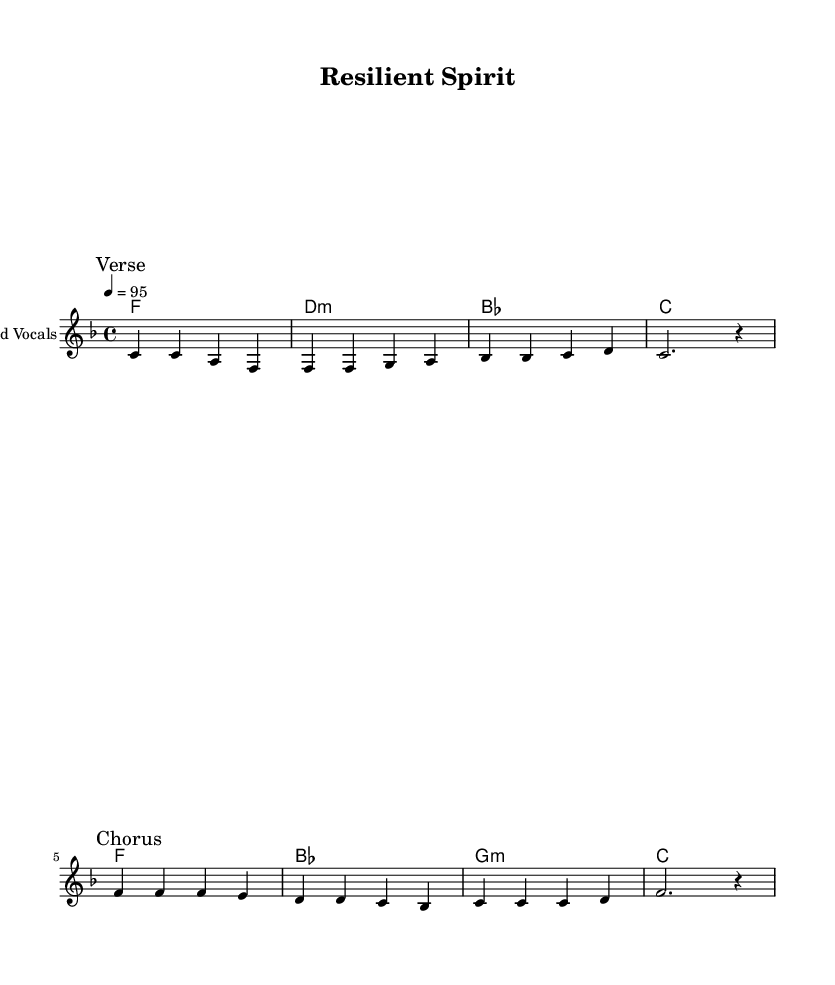What is the key signature of this music? The key signature is F major, identifiable by the presence of one flat (B flat). This can be determined by looking at the beginning of the sheet music where the key signature is indicated.
Answer: F major What is the time signature of this music? The time signature is 4/4, which means there are four beats in each measure and the quarter note gets one beat. This information is located right after the key signature at the beginning of the score.
Answer: 4/4 What is the tempo marking in this piece? The tempo marking indicates a speed of quarter note equals 95 beats per minute, found next to the time signature at the top of the music.
Answer: 95 How many measures are in the chorus? The chorus consists of four measures, which can be counted by analyzing the notation in the chorus section labeled distinctly in the music.
Answer: 4 What is the mood conveyed by the lyrics? The lyrics express determination and resilience in overcoming challenges, which is supported by the uplifting melody and harmonies, reflecting the essence of soul music.
Answer: Resilience What instruments are specified in the score? The score specifies only "Lead Vocals" under the staff for the melody, indicating that the vocal line is the primary focus in this piece.
Answer: Lead Vocals What is the relationship between the verse and chorus lyrics? The verse lyrics discuss standing tall in the face of challenges, while the chorus emphasizes the strength to overcome and achieve victory together. This contrast highlights the journey from struggle to triumph, a common theme in soul music.
Answer: Journey from struggle to triumph 